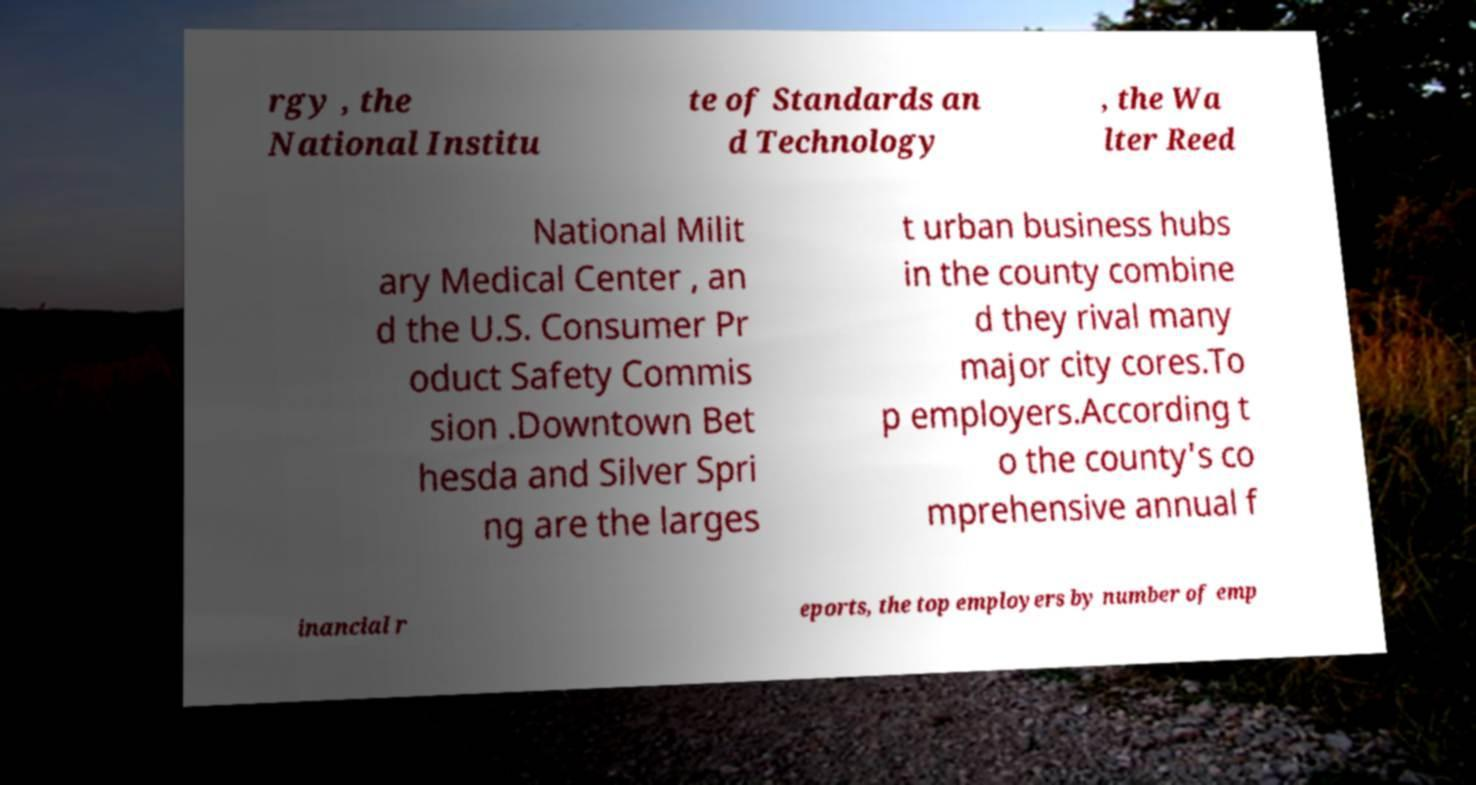Could you assist in decoding the text presented in this image and type it out clearly? rgy , the National Institu te of Standards an d Technology , the Wa lter Reed National Milit ary Medical Center , an d the U.S. Consumer Pr oduct Safety Commis sion .Downtown Bet hesda and Silver Spri ng are the larges t urban business hubs in the county combine d they rival many major city cores.To p employers.According t o the county's co mprehensive annual f inancial r eports, the top employers by number of emp 